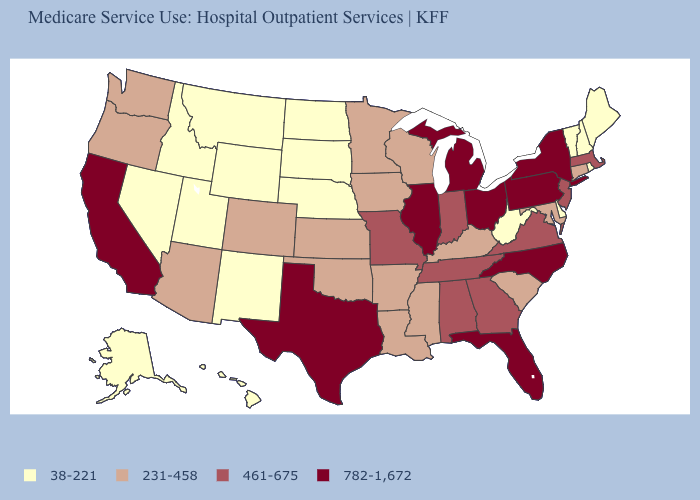What is the highest value in the Northeast ?
Short answer required. 782-1,672. What is the lowest value in the USA?
Answer briefly. 38-221. What is the value of Arkansas?
Answer briefly. 231-458. Name the states that have a value in the range 38-221?
Answer briefly. Alaska, Delaware, Hawaii, Idaho, Maine, Montana, Nebraska, Nevada, New Hampshire, New Mexico, North Dakota, Rhode Island, South Dakota, Utah, Vermont, West Virginia, Wyoming. Does the map have missing data?
Write a very short answer. No. Does the first symbol in the legend represent the smallest category?
Be succinct. Yes. Does Idaho have a higher value than Maryland?
Concise answer only. No. Does Nevada have the highest value in the USA?
Write a very short answer. No. Is the legend a continuous bar?
Short answer required. No. Does Texas have the same value as North Carolina?
Keep it brief. Yes. Which states have the lowest value in the Northeast?
Quick response, please. Maine, New Hampshire, Rhode Island, Vermont. Name the states that have a value in the range 231-458?
Keep it brief. Arizona, Arkansas, Colorado, Connecticut, Iowa, Kansas, Kentucky, Louisiana, Maryland, Minnesota, Mississippi, Oklahoma, Oregon, South Carolina, Washington, Wisconsin. Which states have the lowest value in the USA?
Answer briefly. Alaska, Delaware, Hawaii, Idaho, Maine, Montana, Nebraska, Nevada, New Hampshire, New Mexico, North Dakota, Rhode Island, South Dakota, Utah, Vermont, West Virginia, Wyoming. Which states have the lowest value in the USA?
Concise answer only. Alaska, Delaware, Hawaii, Idaho, Maine, Montana, Nebraska, Nevada, New Hampshire, New Mexico, North Dakota, Rhode Island, South Dakota, Utah, Vermont, West Virginia, Wyoming. 